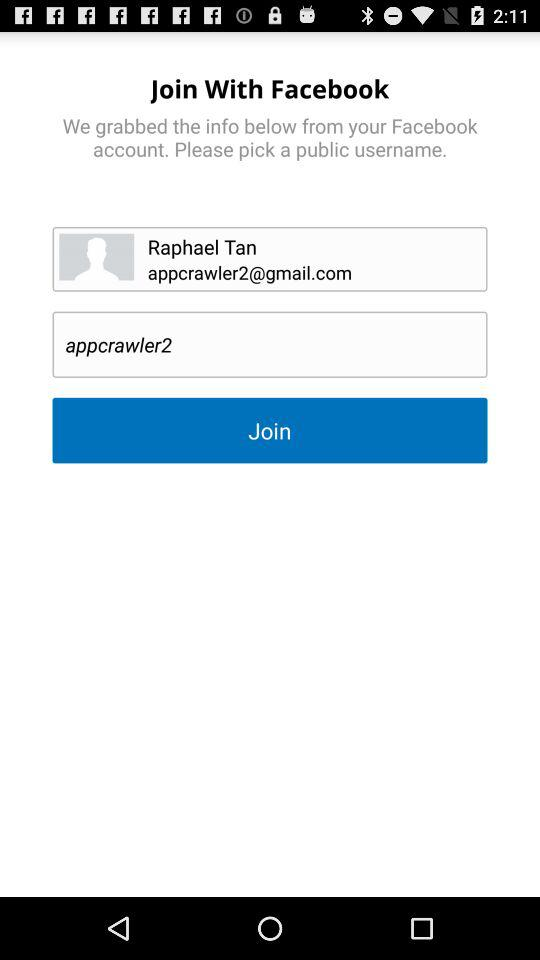Through what application can a user join? The user can join with the Facebook application. 